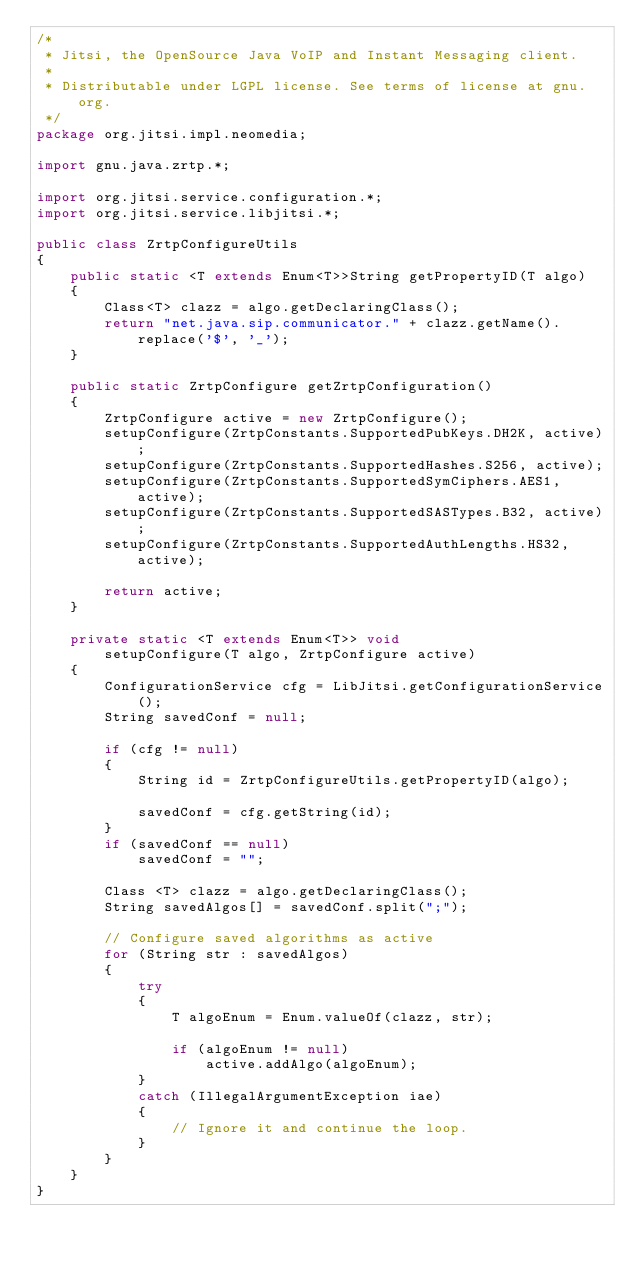Convert code to text. <code><loc_0><loc_0><loc_500><loc_500><_Java_>/*
 * Jitsi, the OpenSource Java VoIP and Instant Messaging client.
 *
 * Distributable under LGPL license. See terms of license at gnu.org.
 */
package org.jitsi.impl.neomedia;

import gnu.java.zrtp.*;

import org.jitsi.service.configuration.*;
import org.jitsi.service.libjitsi.*;

public class ZrtpConfigureUtils
{
    public static <T extends Enum<T>>String getPropertyID(T algo)
    {
        Class<T> clazz = algo.getDeclaringClass();
        return "net.java.sip.communicator." + clazz.getName().replace('$', '_');
    }

    public static ZrtpConfigure getZrtpConfiguration()
    {
        ZrtpConfigure active = new ZrtpConfigure();
        setupConfigure(ZrtpConstants.SupportedPubKeys.DH2K, active);
        setupConfigure(ZrtpConstants.SupportedHashes.S256, active);
        setupConfigure(ZrtpConstants.SupportedSymCiphers.AES1, active);
        setupConfigure(ZrtpConstants.SupportedSASTypes.B32, active);
        setupConfigure(ZrtpConstants.SupportedAuthLengths.HS32, active);

        return active;
    }

    private static <T extends Enum<T>> void
        setupConfigure(T algo, ZrtpConfigure active)
    {
        ConfigurationService cfg = LibJitsi.getConfigurationService();
        String savedConf = null;

        if (cfg != null)
        {
            String id = ZrtpConfigureUtils.getPropertyID(algo);

            savedConf = cfg.getString(id);
        }
        if (savedConf == null)
            savedConf = "";

        Class <T> clazz = algo.getDeclaringClass();
        String savedAlgos[] = savedConf.split(";");

        // Configure saved algorithms as active
        for (String str : savedAlgos)
        {
            try
            {
                T algoEnum = Enum.valueOf(clazz, str);

                if (algoEnum != null)
                    active.addAlgo(algoEnum);
            }
            catch (IllegalArgumentException iae)
            {
                // Ignore it and continue the loop.
            }
        }
    }
}
</code> 